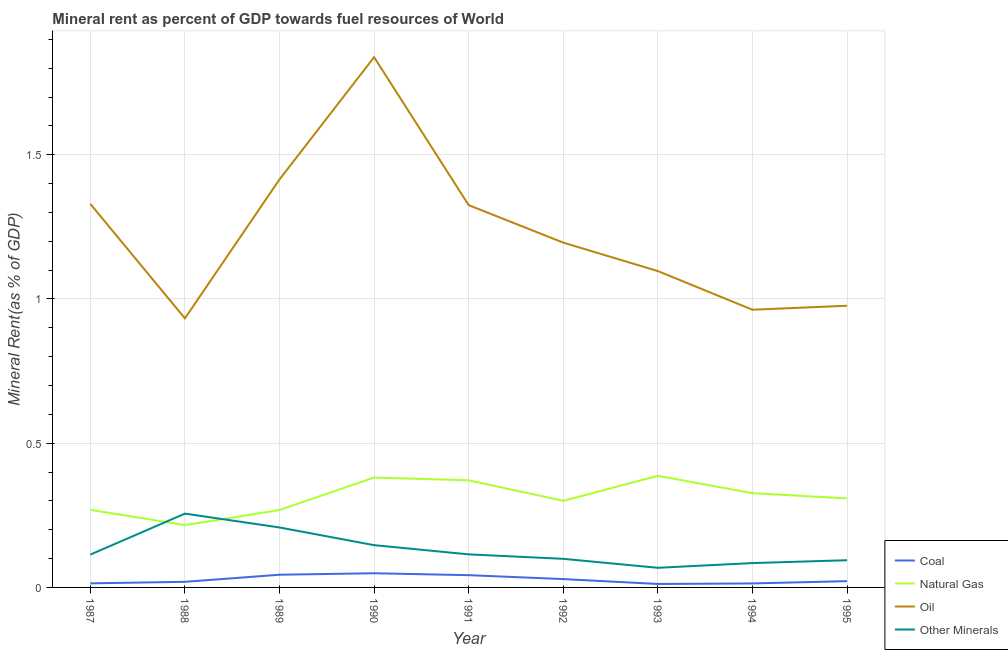How many different coloured lines are there?
Ensure brevity in your answer.  4. Does the line corresponding to natural gas rent intersect with the line corresponding to oil rent?
Offer a terse response. No. Is the number of lines equal to the number of legend labels?
Keep it short and to the point. Yes. What is the natural gas rent in 1991?
Keep it short and to the point. 0.37. Across all years, what is the maximum  rent of other minerals?
Ensure brevity in your answer.  0.26. Across all years, what is the minimum coal rent?
Offer a terse response. 0.01. In which year was the natural gas rent maximum?
Make the answer very short. 1993. In which year was the oil rent minimum?
Provide a succinct answer. 1988. What is the total natural gas rent in the graph?
Your answer should be very brief. 2.83. What is the difference between the oil rent in 1989 and that in 1991?
Your response must be concise. 0.09. What is the difference between the  rent of other minerals in 1987 and the oil rent in 1990?
Offer a terse response. -1.72. What is the average natural gas rent per year?
Provide a short and direct response. 0.31. In the year 1990, what is the difference between the coal rent and natural gas rent?
Your response must be concise. -0.33. In how many years, is the oil rent greater than 1.6 %?
Your answer should be compact. 1. What is the ratio of the coal rent in 1987 to that in 1993?
Provide a succinct answer. 1.18. What is the difference between the highest and the second highest  rent of other minerals?
Provide a succinct answer. 0.05. What is the difference between the highest and the lowest coal rent?
Make the answer very short. 0.04. In how many years, is the  rent of other minerals greater than the average  rent of other minerals taken over all years?
Keep it short and to the point. 3. Is it the case that in every year, the sum of the coal rent and natural gas rent is greater than the oil rent?
Make the answer very short. No. Does the  rent of other minerals monotonically increase over the years?
Provide a succinct answer. No. Is the coal rent strictly greater than the natural gas rent over the years?
Offer a terse response. No. How many years are there in the graph?
Keep it short and to the point. 9. Are the values on the major ticks of Y-axis written in scientific E-notation?
Make the answer very short. No. Where does the legend appear in the graph?
Provide a succinct answer. Bottom right. How are the legend labels stacked?
Give a very brief answer. Vertical. What is the title of the graph?
Provide a succinct answer. Mineral rent as percent of GDP towards fuel resources of World. What is the label or title of the X-axis?
Make the answer very short. Year. What is the label or title of the Y-axis?
Your answer should be compact. Mineral Rent(as % of GDP). What is the Mineral Rent(as % of GDP) of Coal in 1987?
Your answer should be very brief. 0.01. What is the Mineral Rent(as % of GDP) in Natural Gas in 1987?
Your response must be concise. 0.27. What is the Mineral Rent(as % of GDP) of Oil in 1987?
Keep it short and to the point. 1.33. What is the Mineral Rent(as % of GDP) in Other Minerals in 1987?
Your answer should be very brief. 0.11. What is the Mineral Rent(as % of GDP) of Coal in 1988?
Your answer should be very brief. 0.02. What is the Mineral Rent(as % of GDP) in Natural Gas in 1988?
Ensure brevity in your answer.  0.22. What is the Mineral Rent(as % of GDP) in Oil in 1988?
Give a very brief answer. 0.93. What is the Mineral Rent(as % of GDP) in Other Minerals in 1988?
Provide a short and direct response. 0.26. What is the Mineral Rent(as % of GDP) in Coal in 1989?
Your response must be concise. 0.04. What is the Mineral Rent(as % of GDP) in Natural Gas in 1989?
Your answer should be compact. 0.27. What is the Mineral Rent(as % of GDP) of Oil in 1989?
Your answer should be compact. 1.41. What is the Mineral Rent(as % of GDP) in Other Minerals in 1989?
Your answer should be compact. 0.21. What is the Mineral Rent(as % of GDP) of Coal in 1990?
Give a very brief answer. 0.05. What is the Mineral Rent(as % of GDP) of Natural Gas in 1990?
Your answer should be very brief. 0.38. What is the Mineral Rent(as % of GDP) in Oil in 1990?
Make the answer very short. 1.84. What is the Mineral Rent(as % of GDP) in Other Minerals in 1990?
Keep it short and to the point. 0.15. What is the Mineral Rent(as % of GDP) in Coal in 1991?
Offer a very short reply. 0.04. What is the Mineral Rent(as % of GDP) of Natural Gas in 1991?
Offer a terse response. 0.37. What is the Mineral Rent(as % of GDP) of Oil in 1991?
Offer a terse response. 1.33. What is the Mineral Rent(as % of GDP) in Other Minerals in 1991?
Your response must be concise. 0.11. What is the Mineral Rent(as % of GDP) in Coal in 1992?
Your answer should be very brief. 0.03. What is the Mineral Rent(as % of GDP) in Natural Gas in 1992?
Give a very brief answer. 0.3. What is the Mineral Rent(as % of GDP) in Oil in 1992?
Your answer should be compact. 1.2. What is the Mineral Rent(as % of GDP) of Other Minerals in 1992?
Provide a short and direct response. 0.1. What is the Mineral Rent(as % of GDP) of Coal in 1993?
Provide a short and direct response. 0.01. What is the Mineral Rent(as % of GDP) in Natural Gas in 1993?
Make the answer very short. 0.39. What is the Mineral Rent(as % of GDP) in Oil in 1993?
Offer a very short reply. 1.1. What is the Mineral Rent(as % of GDP) of Other Minerals in 1993?
Offer a terse response. 0.07. What is the Mineral Rent(as % of GDP) of Coal in 1994?
Ensure brevity in your answer.  0.01. What is the Mineral Rent(as % of GDP) of Natural Gas in 1994?
Offer a terse response. 0.33. What is the Mineral Rent(as % of GDP) of Oil in 1994?
Offer a very short reply. 0.96. What is the Mineral Rent(as % of GDP) in Other Minerals in 1994?
Keep it short and to the point. 0.08. What is the Mineral Rent(as % of GDP) in Coal in 1995?
Your answer should be compact. 0.02. What is the Mineral Rent(as % of GDP) in Natural Gas in 1995?
Provide a short and direct response. 0.31. What is the Mineral Rent(as % of GDP) in Oil in 1995?
Ensure brevity in your answer.  0.98. What is the Mineral Rent(as % of GDP) in Other Minerals in 1995?
Offer a terse response. 0.09. Across all years, what is the maximum Mineral Rent(as % of GDP) of Coal?
Provide a short and direct response. 0.05. Across all years, what is the maximum Mineral Rent(as % of GDP) of Natural Gas?
Offer a very short reply. 0.39. Across all years, what is the maximum Mineral Rent(as % of GDP) of Oil?
Your answer should be compact. 1.84. Across all years, what is the maximum Mineral Rent(as % of GDP) in Other Minerals?
Your answer should be very brief. 0.26. Across all years, what is the minimum Mineral Rent(as % of GDP) of Coal?
Your answer should be very brief. 0.01. Across all years, what is the minimum Mineral Rent(as % of GDP) in Natural Gas?
Your answer should be compact. 0.22. Across all years, what is the minimum Mineral Rent(as % of GDP) of Oil?
Provide a short and direct response. 0.93. Across all years, what is the minimum Mineral Rent(as % of GDP) in Other Minerals?
Give a very brief answer. 0.07. What is the total Mineral Rent(as % of GDP) of Coal in the graph?
Your answer should be very brief. 0.25. What is the total Mineral Rent(as % of GDP) in Natural Gas in the graph?
Provide a succinct answer. 2.83. What is the total Mineral Rent(as % of GDP) in Oil in the graph?
Provide a short and direct response. 11.07. What is the total Mineral Rent(as % of GDP) of Other Minerals in the graph?
Your response must be concise. 1.18. What is the difference between the Mineral Rent(as % of GDP) of Coal in 1987 and that in 1988?
Your answer should be compact. -0.01. What is the difference between the Mineral Rent(as % of GDP) in Natural Gas in 1987 and that in 1988?
Give a very brief answer. 0.05. What is the difference between the Mineral Rent(as % of GDP) in Oil in 1987 and that in 1988?
Ensure brevity in your answer.  0.4. What is the difference between the Mineral Rent(as % of GDP) in Other Minerals in 1987 and that in 1988?
Provide a short and direct response. -0.14. What is the difference between the Mineral Rent(as % of GDP) in Coal in 1987 and that in 1989?
Offer a terse response. -0.03. What is the difference between the Mineral Rent(as % of GDP) in Natural Gas in 1987 and that in 1989?
Ensure brevity in your answer.  0. What is the difference between the Mineral Rent(as % of GDP) of Oil in 1987 and that in 1989?
Offer a terse response. -0.09. What is the difference between the Mineral Rent(as % of GDP) in Other Minerals in 1987 and that in 1989?
Your answer should be compact. -0.09. What is the difference between the Mineral Rent(as % of GDP) of Coal in 1987 and that in 1990?
Give a very brief answer. -0.04. What is the difference between the Mineral Rent(as % of GDP) of Natural Gas in 1987 and that in 1990?
Make the answer very short. -0.11. What is the difference between the Mineral Rent(as % of GDP) in Oil in 1987 and that in 1990?
Your answer should be very brief. -0.51. What is the difference between the Mineral Rent(as % of GDP) in Other Minerals in 1987 and that in 1990?
Offer a very short reply. -0.03. What is the difference between the Mineral Rent(as % of GDP) of Coal in 1987 and that in 1991?
Offer a very short reply. -0.03. What is the difference between the Mineral Rent(as % of GDP) in Natural Gas in 1987 and that in 1991?
Your answer should be very brief. -0.1. What is the difference between the Mineral Rent(as % of GDP) of Oil in 1987 and that in 1991?
Keep it short and to the point. 0. What is the difference between the Mineral Rent(as % of GDP) of Other Minerals in 1987 and that in 1991?
Your answer should be very brief. -0. What is the difference between the Mineral Rent(as % of GDP) in Coal in 1987 and that in 1992?
Offer a very short reply. -0.01. What is the difference between the Mineral Rent(as % of GDP) of Natural Gas in 1987 and that in 1992?
Offer a very short reply. -0.03. What is the difference between the Mineral Rent(as % of GDP) in Oil in 1987 and that in 1992?
Your answer should be very brief. 0.13. What is the difference between the Mineral Rent(as % of GDP) of Other Minerals in 1987 and that in 1992?
Ensure brevity in your answer.  0.01. What is the difference between the Mineral Rent(as % of GDP) in Coal in 1987 and that in 1993?
Keep it short and to the point. 0. What is the difference between the Mineral Rent(as % of GDP) in Natural Gas in 1987 and that in 1993?
Make the answer very short. -0.12. What is the difference between the Mineral Rent(as % of GDP) of Oil in 1987 and that in 1993?
Your answer should be very brief. 0.23. What is the difference between the Mineral Rent(as % of GDP) in Other Minerals in 1987 and that in 1993?
Offer a terse response. 0.05. What is the difference between the Mineral Rent(as % of GDP) in Natural Gas in 1987 and that in 1994?
Keep it short and to the point. -0.06. What is the difference between the Mineral Rent(as % of GDP) of Oil in 1987 and that in 1994?
Your response must be concise. 0.37. What is the difference between the Mineral Rent(as % of GDP) in Other Minerals in 1987 and that in 1994?
Ensure brevity in your answer.  0.03. What is the difference between the Mineral Rent(as % of GDP) in Coal in 1987 and that in 1995?
Your answer should be very brief. -0.01. What is the difference between the Mineral Rent(as % of GDP) in Natural Gas in 1987 and that in 1995?
Your response must be concise. -0.04. What is the difference between the Mineral Rent(as % of GDP) in Oil in 1987 and that in 1995?
Your answer should be compact. 0.35. What is the difference between the Mineral Rent(as % of GDP) in Other Minerals in 1987 and that in 1995?
Ensure brevity in your answer.  0.02. What is the difference between the Mineral Rent(as % of GDP) in Coal in 1988 and that in 1989?
Your response must be concise. -0.02. What is the difference between the Mineral Rent(as % of GDP) of Natural Gas in 1988 and that in 1989?
Provide a succinct answer. -0.05. What is the difference between the Mineral Rent(as % of GDP) of Oil in 1988 and that in 1989?
Give a very brief answer. -0.48. What is the difference between the Mineral Rent(as % of GDP) of Other Minerals in 1988 and that in 1989?
Offer a terse response. 0.05. What is the difference between the Mineral Rent(as % of GDP) of Coal in 1988 and that in 1990?
Provide a succinct answer. -0.03. What is the difference between the Mineral Rent(as % of GDP) of Natural Gas in 1988 and that in 1990?
Make the answer very short. -0.17. What is the difference between the Mineral Rent(as % of GDP) of Oil in 1988 and that in 1990?
Ensure brevity in your answer.  -0.91. What is the difference between the Mineral Rent(as % of GDP) in Other Minerals in 1988 and that in 1990?
Provide a succinct answer. 0.11. What is the difference between the Mineral Rent(as % of GDP) of Coal in 1988 and that in 1991?
Your answer should be very brief. -0.02. What is the difference between the Mineral Rent(as % of GDP) in Natural Gas in 1988 and that in 1991?
Make the answer very short. -0.16. What is the difference between the Mineral Rent(as % of GDP) in Oil in 1988 and that in 1991?
Your answer should be very brief. -0.39. What is the difference between the Mineral Rent(as % of GDP) of Other Minerals in 1988 and that in 1991?
Give a very brief answer. 0.14. What is the difference between the Mineral Rent(as % of GDP) of Coal in 1988 and that in 1992?
Keep it short and to the point. -0.01. What is the difference between the Mineral Rent(as % of GDP) in Natural Gas in 1988 and that in 1992?
Provide a short and direct response. -0.08. What is the difference between the Mineral Rent(as % of GDP) in Oil in 1988 and that in 1992?
Offer a terse response. -0.26. What is the difference between the Mineral Rent(as % of GDP) in Other Minerals in 1988 and that in 1992?
Your answer should be compact. 0.16. What is the difference between the Mineral Rent(as % of GDP) of Coal in 1988 and that in 1993?
Keep it short and to the point. 0.01. What is the difference between the Mineral Rent(as % of GDP) of Natural Gas in 1988 and that in 1993?
Give a very brief answer. -0.17. What is the difference between the Mineral Rent(as % of GDP) in Oil in 1988 and that in 1993?
Make the answer very short. -0.16. What is the difference between the Mineral Rent(as % of GDP) in Other Minerals in 1988 and that in 1993?
Give a very brief answer. 0.19. What is the difference between the Mineral Rent(as % of GDP) of Coal in 1988 and that in 1994?
Offer a terse response. 0.01. What is the difference between the Mineral Rent(as % of GDP) in Natural Gas in 1988 and that in 1994?
Make the answer very short. -0.11. What is the difference between the Mineral Rent(as % of GDP) in Oil in 1988 and that in 1994?
Your answer should be very brief. -0.03. What is the difference between the Mineral Rent(as % of GDP) in Other Minerals in 1988 and that in 1994?
Provide a short and direct response. 0.17. What is the difference between the Mineral Rent(as % of GDP) of Coal in 1988 and that in 1995?
Provide a succinct answer. -0. What is the difference between the Mineral Rent(as % of GDP) of Natural Gas in 1988 and that in 1995?
Make the answer very short. -0.09. What is the difference between the Mineral Rent(as % of GDP) in Oil in 1988 and that in 1995?
Keep it short and to the point. -0.04. What is the difference between the Mineral Rent(as % of GDP) in Other Minerals in 1988 and that in 1995?
Provide a succinct answer. 0.16. What is the difference between the Mineral Rent(as % of GDP) in Coal in 1989 and that in 1990?
Ensure brevity in your answer.  -0.01. What is the difference between the Mineral Rent(as % of GDP) of Natural Gas in 1989 and that in 1990?
Your answer should be very brief. -0.11. What is the difference between the Mineral Rent(as % of GDP) in Oil in 1989 and that in 1990?
Keep it short and to the point. -0.42. What is the difference between the Mineral Rent(as % of GDP) in Other Minerals in 1989 and that in 1990?
Your answer should be compact. 0.06. What is the difference between the Mineral Rent(as % of GDP) in Coal in 1989 and that in 1991?
Your response must be concise. 0. What is the difference between the Mineral Rent(as % of GDP) in Natural Gas in 1989 and that in 1991?
Give a very brief answer. -0.1. What is the difference between the Mineral Rent(as % of GDP) in Oil in 1989 and that in 1991?
Provide a succinct answer. 0.09. What is the difference between the Mineral Rent(as % of GDP) of Other Minerals in 1989 and that in 1991?
Offer a very short reply. 0.09. What is the difference between the Mineral Rent(as % of GDP) of Coal in 1989 and that in 1992?
Keep it short and to the point. 0.02. What is the difference between the Mineral Rent(as % of GDP) in Natural Gas in 1989 and that in 1992?
Your answer should be very brief. -0.03. What is the difference between the Mineral Rent(as % of GDP) of Oil in 1989 and that in 1992?
Offer a terse response. 0.22. What is the difference between the Mineral Rent(as % of GDP) of Other Minerals in 1989 and that in 1992?
Keep it short and to the point. 0.11. What is the difference between the Mineral Rent(as % of GDP) of Coal in 1989 and that in 1993?
Offer a terse response. 0.03. What is the difference between the Mineral Rent(as % of GDP) in Natural Gas in 1989 and that in 1993?
Offer a terse response. -0.12. What is the difference between the Mineral Rent(as % of GDP) of Oil in 1989 and that in 1993?
Your response must be concise. 0.32. What is the difference between the Mineral Rent(as % of GDP) in Other Minerals in 1989 and that in 1993?
Offer a terse response. 0.14. What is the difference between the Mineral Rent(as % of GDP) of Coal in 1989 and that in 1994?
Ensure brevity in your answer.  0.03. What is the difference between the Mineral Rent(as % of GDP) of Natural Gas in 1989 and that in 1994?
Offer a terse response. -0.06. What is the difference between the Mineral Rent(as % of GDP) of Oil in 1989 and that in 1994?
Keep it short and to the point. 0.45. What is the difference between the Mineral Rent(as % of GDP) of Other Minerals in 1989 and that in 1994?
Offer a terse response. 0.12. What is the difference between the Mineral Rent(as % of GDP) of Coal in 1989 and that in 1995?
Provide a succinct answer. 0.02. What is the difference between the Mineral Rent(as % of GDP) of Natural Gas in 1989 and that in 1995?
Make the answer very short. -0.04. What is the difference between the Mineral Rent(as % of GDP) of Oil in 1989 and that in 1995?
Make the answer very short. 0.44. What is the difference between the Mineral Rent(as % of GDP) in Other Minerals in 1989 and that in 1995?
Offer a very short reply. 0.11. What is the difference between the Mineral Rent(as % of GDP) of Coal in 1990 and that in 1991?
Make the answer very short. 0.01. What is the difference between the Mineral Rent(as % of GDP) in Natural Gas in 1990 and that in 1991?
Make the answer very short. 0.01. What is the difference between the Mineral Rent(as % of GDP) of Oil in 1990 and that in 1991?
Provide a short and direct response. 0.51. What is the difference between the Mineral Rent(as % of GDP) of Other Minerals in 1990 and that in 1991?
Provide a short and direct response. 0.03. What is the difference between the Mineral Rent(as % of GDP) in Coal in 1990 and that in 1992?
Keep it short and to the point. 0.02. What is the difference between the Mineral Rent(as % of GDP) of Natural Gas in 1990 and that in 1992?
Your answer should be compact. 0.08. What is the difference between the Mineral Rent(as % of GDP) of Oil in 1990 and that in 1992?
Keep it short and to the point. 0.64. What is the difference between the Mineral Rent(as % of GDP) of Other Minerals in 1990 and that in 1992?
Provide a succinct answer. 0.05. What is the difference between the Mineral Rent(as % of GDP) in Coal in 1990 and that in 1993?
Offer a very short reply. 0.04. What is the difference between the Mineral Rent(as % of GDP) of Natural Gas in 1990 and that in 1993?
Your answer should be very brief. -0.01. What is the difference between the Mineral Rent(as % of GDP) of Oil in 1990 and that in 1993?
Provide a succinct answer. 0.74. What is the difference between the Mineral Rent(as % of GDP) in Other Minerals in 1990 and that in 1993?
Provide a short and direct response. 0.08. What is the difference between the Mineral Rent(as % of GDP) of Coal in 1990 and that in 1994?
Offer a very short reply. 0.04. What is the difference between the Mineral Rent(as % of GDP) of Natural Gas in 1990 and that in 1994?
Provide a succinct answer. 0.05. What is the difference between the Mineral Rent(as % of GDP) of Oil in 1990 and that in 1994?
Provide a succinct answer. 0.88. What is the difference between the Mineral Rent(as % of GDP) of Other Minerals in 1990 and that in 1994?
Offer a terse response. 0.06. What is the difference between the Mineral Rent(as % of GDP) in Coal in 1990 and that in 1995?
Offer a very short reply. 0.03. What is the difference between the Mineral Rent(as % of GDP) of Natural Gas in 1990 and that in 1995?
Keep it short and to the point. 0.07. What is the difference between the Mineral Rent(as % of GDP) of Oil in 1990 and that in 1995?
Make the answer very short. 0.86. What is the difference between the Mineral Rent(as % of GDP) of Other Minerals in 1990 and that in 1995?
Offer a terse response. 0.05. What is the difference between the Mineral Rent(as % of GDP) of Coal in 1991 and that in 1992?
Your response must be concise. 0.01. What is the difference between the Mineral Rent(as % of GDP) in Natural Gas in 1991 and that in 1992?
Ensure brevity in your answer.  0.07. What is the difference between the Mineral Rent(as % of GDP) of Oil in 1991 and that in 1992?
Provide a succinct answer. 0.13. What is the difference between the Mineral Rent(as % of GDP) in Other Minerals in 1991 and that in 1992?
Provide a short and direct response. 0.02. What is the difference between the Mineral Rent(as % of GDP) in Coal in 1991 and that in 1993?
Offer a terse response. 0.03. What is the difference between the Mineral Rent(as % of GDP) of Natural Gas in 1991 and that in 1993?
Your response must be concise. -0.02. What is the difference between the Mineral Rent(as % of GDP) in Oil in 1991 and that in 1993?
Make the answer very short. 0.23. What is the difference between the Mineral Rent(as % of GDP) in Other Minerals in 1991 and that in 1993?
Offer a very short reply. 0.05. What is the difference between the Mineral Rent(as % of GDP) of Coal in 1991 and that in 1994?
Ensure brevity in your answer.  0.03. What is the difference between the Mineral Rent(as % of GDP) of Natural Gas in 1991 and that in 1994?
Give a very brief answer. 0.04. What is the difference between the Mineral Rent(as % of GDP) of Oil in 1991 and that in 1994?
Make the answer very short. 0.36. What is the difference between the Mineral Rent(as % of GDP) of Other Minerals in 1991 and that in 1994?
Ensure brevity in your answer.  0.03. What is the difference between the Mineral Rent(as % of GDP) of Coal in 1991 and that in 1995?
Your answer should be very brief. 0.02. What is the difference between the Mineral Rent(as % of GDP) of Natural Gas in 1991 and that in 1995?
Your response must be concise. 0.06. What is the difference between the Mineral Rent(as % of GDP) of Oil in 1991 and that in 1995?
Offer a very short reply. 0.35. What is the difference between the Mineral Rent(as % of GDP) of Other Minerals in 1991 and that in 1995?
Provide a succinct answer. 0.02. What is the difference between the Mineral Rent(as % of GDP) of Coal in 1992 and that in 1993?
Provide a succinct answer. 0.02. What is the difference between the Mineral Rent(as % of GDP) of Natural Gas in 1992 and that in 1993?
Your answer should be very brief. -0.09. What is the difference between the Mineral Rent(as % of GDP) in Oil in 1992 and that in 1993?
Ensure brevity in your answer.  0.1. What is the difference between the Mineral Rent(as % of GDP) of Other Minerals in 1992 and that in 1993?
Your response must be concise. 0.03. What is the difference between the Mineral Rent(as % of GDP) of Coal in 1992 and that in 1994?
Your answer should be very brief. 0.02. What is the difference between the Mineral Rent(as % of GDP) of Natural Gas in 1992 and that in 1994?
Your response must be concise. -0.03. What is the difference between the Mineral Rent(as % of GDP) of Oil in 1992 and that in 1994?
Make the answer very short. 0.23. What is the difference between the Mineral Rent(as % of GDP) in Other Minerals in 1992 and that in 1994?
Give a very brief answer. 0.01. What is the difference between the Mineral Rent(as % of GDP) in Coal in 1992 and that in 1995?
Your answer should be very brief. 0.01. What is the difference between the Mineral Rent(as % of GDP) of Natural Gas in 1992 and that in 1995?
Offer a very short reply. -0.01. What is the difference between the Mineral Rent(as % of GDP) in Oil in 1992 and that in 1995?
Your answer should be very brief. 0.22. What is the difference between the Mineral Rent(as % of GDP) in Other Minerals in 1992 and that in 1995?
Provide a short and direct response. 0. What is the difference between the Mineral Rent(as % of GDP) in Coal in 1993 and that in 1994?
Give a very brief answer. -0. What is the difference between the Mineral Rent(as % of GDP) in Natural Gas in 1993 and that in 1994?
Your answer should be very brief. 0.06. What is the difference between the Mineral Rent(as % of GDP) of Oil in 1993 and that in 1994?
Provide a succinct answer. 0.13. What is the difference between the Mineral Rent(as % of GDP) of Other Minerals in 1993 and that in 1994?
Your answer should be compact. -0.02. What is the difference between the Mineral Rent(as % of GDP) in Coal in 1993 and that in 1995?
Offer a terse response. -0.01. What is the difference between the Mineral Rent(as % of GDP) in Natural Gas in 1993 and that in 1995?
Your answer should be compact. 0.08. What is the difference between the Mineral Rent(as % of GDP) in Oil in 1993 and that in 1995?
Your answer should be very brief. 0.12. What is the difference between the Mineral Rent(as % of GDP) of Other Minerals in 1993 and that in 1995?
Your response must be concise. -0.03. What is the difference between the Mineral Rent(as % of GDP) in Coal in 1994 and that in 1995?
Your answer should be compact. -0.01. What is the difference between the Mineral Rent(as % of GDP) of Natural Gas in 1994 and that in 1995?
Your response must be concise. 0.02. What is the difference between the Mineral Rent(as % of GDP) in Oil in 1994 and that in 1995?
Keep it short and to the point. -0.01. What is the difference between the Mineral Rent(as % of GDP) of Other Minerals in 1994 and that in 1995?
Keep it short and to the point. -0.01. What is the difference between the Mineral Rent(as % of GDP) of Coal in 1987 and the Mineral Rent(as % of GDP) of Natural Gas in 1988?
Offer a terse response. -0.2. What is the difference between the Mineral Rent(as % of GDP) of Coal in 1987 and the Mineral Rent(as % of GDP) of Oil in 1988?
Provide a short and direct response. -0.92. What is the difference between the Mineral Rent(as % of GDP) in Coal in 1987 and the Mineral Rent(as % of GDP) in Other Minerals in 1988?
Your answer should be compact. -0.24. What is the difference between the Mineral Rent(as % of GDP) of Natural Gas in 1987 and the Mineral Rent(as % of GDP) of Oil in 1988?
Offer a very short reply. -0.66. What is the difference between the Mineral Rent(as % of GDP) of Natural Gas in 1987 and the Mineral Rent(as % of GDP) of Other Minerals in 1988?
Provide a short and direct response. 0.01. What is the difference between the Mineral Rent(as % of GDP) in Oil in 1987 and the Mineral Rent(as % of GDP) in Other Minerals in 1988?
Your answer should be compact. 1.07. What is the difference between the Mineral Rent(as % of GDP) of Coal in 1987 and the Mineral Rent(as % of GDP) of Natural Gas in 1989?
Make the answer very short. -0.25. What is the difference between the Mineral Rent(as % of GDP) of Coal in 1987 and the Mineral Rent(as % of GDP) of Oil in 1989?
Offer a terse response. -1.4. What is the difference between the Mineral Rent(as % of GDP) of Coal in 1987 and the Mineral Rent(as % of GDP) of Other Minerals in 1989?
Ensure brevity in your answer.  -0.19. What is the difference between the Mineral Rent(as % of GDP) of Natural Gas in 1987 and the Mineral Rent(as % of GDP) of Oil in 1989?
Offer a terse response. -1.15. What is the difference between the Mineral Rent(as % of GDP) of Natural Gas in 1987 and the Mineral Rent(as % of GDP) of Other Minerals in 1989?
Your answer should be compact. 0.06. What is the difference between the Mineral Rent(as % of GDP) in Oil in 1987 and the Mineral Rent(as % of GDP) in Other Minerals in 1989?
Offer a very short reply. 1.12. What is the difference between the Mineral Rent(as % of GDP) in Coal in 1987 and the Mineral Rent(as % of GDP) in Natural Gas in 1990?
Your answer should be compact. -0.37. What is the difference between the Mineral Rent(as % of GDP) of Coal in 1987 and the Mineral Rent(as % of GDP) of Oil in 1990?
Provide a succinct answer. -1.82. What is the difference between the Mineral Rent(as % of GDP) of Coal in 1987 and the Mineral Rent(as % of GDP) of Other Minerals in 1990?
Your response must be concise. -0.13. What is the difference between the Mineral Rent(as % of GDP) in Natural Gas in 1987 and the Mineral Rent(as % of GDP) in Oil in 1990?
Ensure brevity in your answer.  -1.57. What is the difference between the Mineral Rent(as % of GDP) in Natural Gas in 1987 and the Mineral Rent(as % of GDP) in Other Minerals in 1990?
Make the answer very short. 0.12. What is the difference between the Mineral Rent(as % of GDP) of Oil in 1987 and the Mineral Rent(as % of GDP) of Other Minerals in 1990?
Your answer should be compact. 1.18. What is the difference between the Mineral Rent(as % of GDP) in Coal in 1987 and the Mineral Rent(as % of GDP) in Natural Gas in 1991?
Provide a succinct answer. -0.36. What is the difference between the Mineral Rent(as % of GDP) of Coal in 1987 and the Mineral Rent(as % of GDP) of Oil in 1991?
Your answer should be compact. -1.31. What is the difference between the Mineral Rent(as % of GDP) of Coal in 1987 and the Mineral Rent(as % of GDP) of Other Minerals in 1991?
Ensure brevity in your answer.  -0.1. What is the difference between the Mineral Rent(as % of GDP) of Natural Gas in 1987 and the Mineral Rent(as % of GDP) of Oil in 1991?
Your answer should be very brief. -1.06. What is the difference between the Mineral Rent(as % of GDP) of Natural Gas in 1987 and the Mineral Rent(as % of GDP) of Other Minerals in 1991?
Give a very brief answer. 0.15. What is the difference between the Mineral Rent(as % of GDP) of Oil in 1987 and the Mineral Rent(as % of GDP) of Other Minerals in 1991?
Your response must be concise. 1.21. What is the difference between the Mineral Rent(as % of GDP) in Coal in 1987 and the Mineral Rent(as % of GDP) in Natural Gas in 1992?
Make the answer very short. -0.29. What is the difference between the Mineral Rent(as % of GDP) in Coal in 1987 and the Mineral Rent(as % of GDP) in Oil in 1992?
Offer a very short reply. -1.18. What is the difference between the Mineral Rent(as % of GDP) of Coal in 1987 and the Mineral Rent(as % of GDP) of Other Minerals in 1992?
Your answer should be very brief. -0.09. What is the difference between the Mineral Rent(as % of GDP) in Natural Gas in 1987 and the Mineral Rent(as % of GDP) in Oil in 1992?
Your response must be concise. -0.93. What is the difference between the Mineral Rent(as % of GDP) in Natural Gas in 1987 and the Mineral Rent(as % of GDP) in Other Minerals in 1992?
Your answer should be compact. 0.17. What is the difference between the Mineral Rent(as % of GDP) of Oil in 1987 and the Mineral Rent(as % of GDP) of Other Minerals in 1992?
Offer a very short reply. 1.23. What is the difference between the Mineral Rent(as % of GDP) in Coal in 1987 and the Mineral Rent(as % of GDP) in Natural Gas in 1993?
Keep it short and to the point. -0.37. What is the difference between the Mineral Rent(as % of GDP) in Coal in 1987 and the Mineral Rent(as % of GDP) in Oil in 1993?
Provide a short and direct response. -1.08. What is the difference between the Mineral Rent(as % of GDP) of Coal in 1987 and the Mineral Rent(as % of GDP) of Other Minerals in 1993?
Offer a terse response. -0.05. What is the difference between the Mineral Rent(as % of GDP) of Natural Gas in 1987 and the Mineral Rent(as % of GDP) of Oil in 1993?
Your answer should be compact. -0.83. What is the difference between the Mineral Rent(as % of GDP) of Natural Gas in 1987 and the Mineral Rent(as % of GDP) of Other Minerals in 1993?
Your response must be concise. 0.2. What is the difference between the Mineral Rent(as % of GDP) in Oil in 1987 and the Mineral Rent(as % of GDP) in Other Minerals in 1993?
Your answer should be compact. 1.26. What is the difference between the Mineral Rent(as % of GDP) of Coal in 1987 and the Mineral Rent(as % of GDP) of Natural Gas in 1994?
Give a very brief answer. -0.31. What is the difference between the Mineral Rent(as % of GDP) in Coal in 1987 and the Mineral Rent(as % of GDP) in Oil in 1994?
Provide a short and direct response. -0.95. What is the difference between the Mineral Rent(as % of GDP) of Coal in 1987 and the Mineral Rent(as % of GDP) of Other Minerals in 1994?
Make the answer very short. -0.07. What is the difference between the Mineral Rent(as % of GDP) in Natural Gas in 1987 and the Mineral Rent(as % of GDP) in Oil in 1994?
Your response must be concise. -0.69. What is the difference between the Mineral Rent(as % of GDP) of Natural Gas in 1987 and the Mineral Rent(as % of GDP) of Other Minerals in 1994?
Ensure brevity in your answer.  0.18. What is the difference between the Mineral Rent(as % of GDP) of Oil in 1987 and the Mineral Rent(as % of GDP) of Other Minerals in 1994?
Your response must be concise. 1.25. What is the difference between the Mineral Rent(as % of GDP) in Coal in 1987 and the Mineral Rent(as % of GDP) in Natural Gas in 1995?
Offer a terse response. -0.29. What is the difference between the Mineral Rent(as % of GDP) in Coal in 1987 and the Mineral Rent(as % of GDP) in Oil in 1995?
Offer a very short reply. -0.96. What is the difference between the Mineral Rent(as % of GDP) in Coal in 1987 and the Mineral Rent(as % of GDP) in Other Minerals in 1995?
Provide a succinct answer. -0.08. What is the difference between the Mineral Rent(as % of GDP) in Natural Gas in 1987 and the Mineral Rent(as % of GDP) in Oil in 1995?
Provide a short and direct response. -0.71. What is the difference between the Mineral Rent(as % of GDP) in Natural Gas in 1987 and the Mineral Rent(as % of GDP) in Other Minerals in 1995?
Make the answer very short. 0.17. What is the difference between the Mineral Rent(as % of GDP) in Oil in 1987 and the Mineral Rent(as % of GDP) in Other Minerals in 1995?
Give a very brief answer. 1.24. What is the difference between the Mineral Rent(as % of GDP) of Coal in 1988 and the Mineral Rent(as % of GDP) of Natural Gas in 1989?
Your answer should be compact. -0.25. What is the difference between the Mineral Rent(as % of GDP) of Coal in 1988 and the Mineral Rent(as % of GDP) of Oil in 1989?
Your response must be concise. -1.4. What is the difference between the Mineral Rent(as % of GDP) of Coal in 1988 and the Mineral Rent(as % of GDP) of Other Minerals in 1989?
Keep it short and to the point. -0.19. What is the difference between the Mineral Rent(as % of GDP) of Natural Gas in 1988 and the Mineral Rent(as % of GDP) of Oil in 1989?
Provide a succinct answer. -1.2. What is the difference between the Mineral Rent(as % of GDP) of Natural Gas in 1988 and the Mineral Rent(as % of GDP) of Other Minerals in 1989?
Your answer should be very brief. 0.01. What is the difference between the Mineral Rent(as % of GDP) in Oil in 1988 and the Mineral Rent(as % of GDP) in Other Minerals in 1989?
Provide a succinct answer. 0.72. What is the difference between the Mineral Rent(as % of GDP) of Coal in 1988 and the Mineral Rent(as % of GDP) of Natural Gas in 1990?
Provide a succinct answer. -0.36. What is the difference between the Mineral Rent(as % of GDP) of Coal in 1988 and the Mineral Rent(as % of GDP) of Oil in 1990?
Keep it short and to the point. -1.82. What is the difference between the Mineral Rent(as % of GDP) of Coal in 1988 and the Mineral Rent(as % of GDP) of Other Minerals in 1990?
Your answer should be compact. -0.13. What is the difference between the Mineral Rent(as % of GDP) in Natural Gas in 1988 and the Mineral Rent(as % of GDP) in Oil in 1990?
Give a very brief answer. -1.62. What is the difference between the Mineral Rent(as % of GDP) of Natural Gas in 1988 and the Mineral Rent(as % of GDP) of Other Minerals in 1990?
Make the answer very short. 0.07. What is the difference between the Mineral Rent(as % of GDP) in Oil in 1988 and the Mineral Rent(as % of GDP) in Other Minerals in 1990?
Keep it short and to the point. 0.79. What is the difference between the Mineral Rent(as % of GDP) of Coal in 1988 and the Mineral Rent(as % of GDP) of Natural Gas in 1991?
Your response must be concise. -0.35. What is the difference between the Mineral Rent(as % of GDP) of Coal in 1988 and the Mineral Rent(as % of GDP) of Oil in 1991?
Your answer should be compact. -1.31. What is the difference between the Mineral Rent(as % of GDP) in Coal in 1988 and the Mineral Rent(as % of GDP) in Other Minerals in 1991?
Keep it short and to the point. -0.1. What is the difference between the Mineral Rent(as % of GDP) in Natural Gas in 1988 and the Mineral Rent(as % of GDP) in Oil in 1991?
Your answer should be compact. -1.11. What is the difference between the Mineral Rent(as % of GDP) in Natural Gas in 1988 and the Mineral Rent(as % of GDP) in Other Minerals in 1991?
Give a very brief answer. 0.1. What is the difference between the Mineral Rent(as % of GDP) of Oil in 1988 and the Mineral Rent(as % of GDP) of Other Minerals in 1991?
Provide a short and direct response. 0.82. What is the difference between the Mineral Rent(as % of GDP) in Coal in 1988 and the Mineral Rent(as % of GDP) in Natural Gas in 1992?
Ensure brevity in your answer.  -0.28. What is the difference between the Mineral Rent(as % of GDP) in Coal in 1988 and the Mineral Rent(as % of GDP) in Oil in 1992?
Provide a succinct answer. -1.18. What is the difference between the Mineral Rent(as % of GDP) in Coal in 1988 and the Mineral Rent(as % of GDP) in Other Minerals in 1992?
Make the answer very short. -0.08. What is the difference between the Mineral Rent(as % of GDP) of Natural Gas in 1988 and the Mineral Rent(as % of GDP) of Oil in 1992?
Your answer should be compact. -0.98. What is the difference between the Mineral Rent(as % of GDP) of Natural Gas in 1988 and the Mineral Rent(as % of GDP) of Other Minerals in 1992?
Offer a terse response. 0.12. What is the difference between the Mineral Rent(as % of GDP) in Oil in 1988 and the Mineral Rent(as % of GDP) in Other Minerals in 1992?
Your answer should be compact. 0.83. What is the difference between the Mineral Rent(as % of GDP) in Coal in 1988 and the Mineral Rent(as % of GDP) in Natural Gas in 1993?
Offer a very short reply. -0.37. What is the difference between the Mineral Rent(as % of GDP) in Coal in 1988 and the Mineral Rent(as % of GDP) in Oil in 1993?
Ensure brevity in your answer.  -1.08. What is the difference between the Mineral Rent(as % of GDP) of Coal in 1988 and the Mineral Rent(as % of GDP) of Other Minerals in 1993?
Offer a terse response. -0.05. What is the difference between the Mineral Rent(as % of GDP) of Natural Gas in 1988 and the Mineral Rent(as % of GDP) of Oil in 1993?
Make the answer very short. -0.88. What is the difference between the Mineral Rent(as % of GDP) of Natural Gas in 1988 and the Mineral Rent(as % of GDP) of Other Minerals in 1993?
Ensure brevity in your answer.  0.15. What is the difference between the Mineral Rent(as % of GDP) of Oil in 1988 and the Mineral Rent(as % of GDP) of Other Minerals in 1993?
Give a very brief answer. 0.86. What is the difference between the Mineral Rent(as % of GDP) in Coal in 1988 and the Mineral Rent(as % of GDP) in Natural Gas in 1994?
Provide a succinct answer. -0.31. What is the difference between the Mineral Rent(as % of GDP) in Coal in 1988 and the Mineral Rent(as % of GDP) in Oil in 1994?
Offer a very short reply. -0.94. What is the difference between the Mineral Rent(as % of GDP) of Coal in 1988 and the Mineral Rent(as % of GDP) of Other Minerals in 1994?
Give a very brief answer. -0.07. What is the difference between the Mineral Rent(as % of GDP) in Natural Gas in 1988 and the Mineral Rent(as % of GDP) in Oil in 1994?
Ensure brevity in your answer.  -0.75. What is the difference between the Mineral Rent(as % of GDP) of Natural Gas in 1988 and the Mineral Rent(as % of GDP) of Other Minerals in 1994?
Provide a short and direct response. 0.13. What is the difference between the Mineral Rent(as % of GDP) in Oil in 1988 and the Mineral Rent(as % of GDP) in Other Minerals in 1994?
Make the answer very short. 0.85. What is the difference between the Mineral Rent(as % of GDP) in Coal in 1988 and the Mineral Rent(as % of GDP) in Natural Gas in 1995?
Provide a succinct answer. -0.29. What is the difference between the Mineral Rent(as % of GDP) in Coal in 1988 and the Mineral Rent(as % of GDP) in Oil in 1995?
Offer a very short reply. -0.96. What is the difference between the Mineral Rent(as % of GDP) in Coal in 1988 and the Mineral Rent(as % of GDP) in Other Minerals in 1995?
Keep it short and to the point. -0.07. What is the difference between the Mineral Rent(as % of GDP) in Natural Gas in 1988 and the Mineral Rent(as % of GDP) in Oil in 1995?
Your answer should be compact. -0.76. What is the difference between the Mineral Rent(as % of GDP) in Natural Gas in 1988 and the Mineral Rent(as % of GDP) in Other Minerals in 1995?
Make the answer very short. 0.12. What is the difference between the Mineral Rent(as % of GDP) in Oil in 1988 and the Mineral Rent(as % of GDP) in Other Minerals in 1995?
Ensure brevity in your answer.  0.84. What is the difference between the Mineral Rent(as % of GDP) of Coal in 1989 and the Mineral Rent(as % of GDP) of Natural Gas in 1990?
Provide a short and direct response. -0.34. What is the difference between the Mineral Rent(as % of GDP) of Coal in 1989 and the Mineral Rent(as % of GDP) of Oil in 1990?
Keep it short and to the point. -1.79. What is the difference between the Mineral Rent(as % of GDP) of Coal in 1989 and the Mineral Rent(as % of GDP) of Other Minerals in 1990?
Provide a short and direct response. -0.1. What is the difference between the Mineral Rent(as % of GDP) of Natural Gas in 1989 and the Mineral Rent(as % of GDP) of Oil in 1990?
Your response must be concise. -1.57. What is the difference between the Mineral Rent(as % of GDP) of Natural Gas in 1989 and the Mineral Rent(as % of GDP) of Other Minerals in 1990?
Ensure brevity in your answer.  0.12. What is the difference between the Mineral Rent(as % of GDP) in Oil in 1989 and the Mineral Rent(as % of GDP) in Other Minerals in 1990?
Your response must be concise. 1.27. What is the difference between the Mineral Rent(as % of GDP) in Coal in 1989 and the Mineral Rent(as % of GDP) in Natural Gas in 1991?
Provide a succinct answer. -0.33. What is the difference between the Mineral Rent(as % of GDP) in Coal in 1989 and the Mineral Rent(as % of GDP) in Oil in 1991?
Your answer should be very brief. -1.28. What is the difference between the Mineral Rent(as % of GDP) in Coal in 1989 and the Mineral Rent(as % of GDP) in Other Minerals in 1991?
Your response must be concise. -0.07. What is the difference between the Mineral Rent(as % of GDP) of Natural Gas in 1989 and the Mineral Rent(as % of GDP) of Oil in 1991?
Offer a very short reply. -1.06. What is the difference between the Mineral Rent(as % of GDP) of Natural Gas in 1989 and the Mineral Rent(as % of GDP) of Other Minerals in 1991?
Make the answer very short. 0.15. What is the difference between the Mineral Rent(as % of GDP) of Oil in 1989 and the Mineral Rent(as % of GDP) of Other Minerals in 1991?
Ensure brevity in your answer.  1.3. What is the difference between the Mineral Rent(as % of GDP) of Coal in 1989 and the Mineral Rent(as % of GDP) of Natural Gas in 1992?
Offer a very short reply. -0.26. What is the difference between the Mineral Rent(as % of GDP) in Coal in 1989 and the Mineral Rent(as % of GDP) in Oil in 1992?
Make the answer very short. -1.15. What is the difference between the Mineral Rent(as % of GDP) of Coal in 1989 and the Mineral Rent(as % of GDP) of Other Minerals in 1992?
Keep it short and to the point. -0.06. What is the difference between the Mineral Rent(as % of GDP) in Natural Gas in 1989 and the Mineral Rent(as % of GDP) in Oil in 1992?
Offer a very short reply. -0.93. What is the difference between the Mineral Rent(as % of GDP) in Natural Gas in 1989 and the Mineral Rent(as % of GDP) in Other Minerals in 1992?
Your answer should be compact. 0.17. What is the difference between the Mineral Rent(as % of GDP) of Oil in 1989 and the Mineral Rent(as % of GDP) of Other Minerals in 1992?
Your answer should be very brief. 1.32. What is the difference between the Mineral Rent(as % of GDP) of Coal in 1989 and the Mineral Rent(as % of GDP) of Natural Gas in 1993?
Your response must be concise. -0.34. What is the difference between the Mineral Rent(as % of GDP) of Coal in 1989 and the Mineral Rent(as % of GDP) of Oil in 1993?
Your answer should be very brief. -1.05. What is the difference between the Mineral Rent(as % of GDP) in Coal in 1989 and the Mineral Rent(as % of GDP) in Other Minerals in 1993?
Offer a terse response. -0.02. What is the difference between the Mineral Rent(as % of GDP) in Natural Gas in 1989 and the Mineral Rent(as % of GDP) in Oil in 1993?
Give a very brief answer. -0.83. What is the difference between the Mineral Rent(as % of GDP) in Natural Gas in 1989 and the Mineral Rent(as % of GDP) in Other Minerals in 1993?
Ensure brevity in your answer.  0.2. What is the difference between the Mineral Rent(as % of GDP) in Oil in 1989 and the Mineral Rent(as % of GDP) in Other Minerals in 1993?
Your answer should be very brief. 1.35. What is the difference between the Mineral Rent(as % of GDP) of Coal in 1989 and the Mineral Rent(as % of GDP) of Natural Gas in 1994?
Make the answer very short. -0.28. What is the difference between the Mineral Rent(as % of GDP) in Coal in 1989 and the Mineral Rent(as % of GDP) in Oil in 1994?
Make the answer very short. -0.92. What is the difference between the Mineral Rent(as % of GDP) in Coal in 1989 and the Mineral Rent(as % of GDP) in Other Minerals in 1994?
Keep it short and to the point. -0.04. What is the difference between the Mineral Rent(as % of GDP) of Natural Gas in 1989 and the Mineral Rent(as % of GDP) of Oil in 1994?
Make the answer very short. -0.69. What is the difference between the Mineral Rent(as % of GDP) of Natural Gas in 1989 and the Mineral Rent(as % of GDP) of Other Minerals in 1994?
Give a very brief answer. 0.18. What is the difference between the Mineral Rent(as % of GDP) of Oil in 1989 and the Mineral Rent(as % of GDP) of Other Minerals in 1994?
Provide a short and direct response. 1.33. What is the difference between the Mineral Rent(as % of GDP) of Coal in 1989 and the Mineral Rent(as % of GDP) of Natural Gas in 1995?
Keep it short and to the point. -0.26. What is the difference between the Mineral Rent(as % of GDP) in Coal in 1989 and the Mineral Rent(as % of GDP) in Oil in 1995?
Make the answer very short. -0.93. What is the difference between the Mineral Rent(as % of GDP) of Coal in 1989 and the Mineral Rent(as % of GDP) of Other Minerals in 1995?
Ensure brevity in your answer.  -0.05. What is the difference between the Mineral Rent(as % of GDP) in Natural Gas in 1989 and the Mineral Rent(as % of GDP) in Oil in 1995?
Keep it short and to the point. -0.71. What is the difference between the Mineral Rent(as % of GDP) in Natural Gas in 1989 and the Mineral Rent(as % of GDP) in Other Minerals in 1995?
Offer a terse response. 0.17. What is the difference between the Mineral Rent(as % of GDP) in Oil in 1989 and the Mineral Rent(as % of GDP) in Other Minerals in 1995?
Ensure brevity in your answer.  1.32. What is the difference between the Mineral Rent(as % of GDP) in Coal in 1990 and the Mineral Rent(as % of GDP) in Natural Gas in 1991?
Your answer should be compact. -0.32. What is the difference between the Mineral Rent(as % of GDP) of Coal in 1990 and the Mineral Rent(as % of GDP) of Oil in 1991?
Provide a succinct answer. -1.28. What is the difference between the Mineral Rent(as % of GDP) of Coal in 1990 and the Mineral Rent(as % of GDP) of Other Minerals in 1991?
Make the answer very short. -0.07. What is the difference between the Mineral Rent(as % of GDP) in Natural Gas in 1990 and the Mineral Rent(as % of GDP) in Oil in 1991?
Keep it short and to the point. -0.94. What is the difference between the Mineral Rent(as % of GDP) in Natural Gas in 1990 and the Mineral Rent(as % of GDP) in Other Minerals in 1991?
Give a very brief answer. 0.27. What is the difference between the Mineral Rent(as % of GDP) of Oil in 1990 and the Mineral Rent(as % of GDP) of Other Minerals in 1991?
Provide a succinct answer. 1.72. What is the difference between the Mineral Rent(as % of GDP) of Coal in 1990 and the Mineral Rent(as % of GDP) of Natural Gas in 1992?
Offer a terse response. -0.25. What is the difference between the Mineral Rent(as % of GDP) in Coal in 1990 and the Mineral Rent(as % of GDP) in Oil in 1992?
Your response must be concise. -1.15. What is the difference between the Mineral Rent(as % of GDP) in Coal in 1990 and the Mineral Rent(as % of GDP) in Other Minerals in 1992?
Ensure brevity in your answer.  -0.05. What is the difference between the Mineral Rent(as % of GDP) of Natural Gas in 1990 and the Mineral Rent(as % of GDP) of Oil in 1992?
Your response must be concise. -0.81. What is the difference between the Mineral Rent(as % of GDP) in Natural Gas in 1990 and the Mineral Rent(as % of GDP) in Other Minerals in 1992?
Your response must be concise. 0.28. What is the difference between the Mineral Rent(as % of GDP) of Oil in 1990 and the Mineral Rent(as % of GDP) of Other Minerals in 1992?
Provide a short and direct response. 1.74. What is the difference between the Mineral Rent(as % of GDP) in Coal in 1990 and the Mineral Rent(as % of GDP) in Natural Gas in 1993?
Your answer should be very brief. -0.34. What is the difference between the Mineral Rent(as % of GDP) in Coal in 1990 and the Mineral Rent(as % of GDP) in Oil in 1993?
Ensure brevity in your answer.  -1.05. What is the difference between the Mineral Rent(as % of GDP) of Coal in 1990 and the Mineral Rent(as % of GDP) of Other Minerals in 1993?
Your answer should be compact. -0.02. What is the difference between the Mineral Rent(as % of GDP) of Natural Gas in 1990 and the Mineral Rent(as % of GDP) of Oil in 1993?
Offer a very short reply. -0.72. What is the difference between the Mineral Rent(as % of GDP) in Natural Gas in 1990 and the Mineral Rent(as % of GDP) in Other Minerals in 1993?
Keep it short and to the point. 0.31. What is the difference between the Mineral Rent(as % of GDP) of Oil in 1990 and the Mineral Rent(as % of GDP) of Other Minerals in 1993?
Offer a terse response. 1.77. What is the difference between the Mineral Rent(as % of GDP) in Coal in 1990 and the Mineral Rent(as % of GDP) in Natural Gas in 1994?
Provide a short and direct response. -0.28. What is the difference between the Mineral Rent(as % of GDP) of Coal in 1990 and the Mineral Rent(as % of GDP) of Oil in 1994?
Ensure brevity in your answer.  -0.91. What is the difference between the Mineral Rent(as % of GDP) of Coal in 1990 and the Mineral Rent(as % of GDP) of Other Minerals in 1994?
Your response must be concise. -0.04. What is the difference between the Mineral Rent(as % of GDP) in Natural Gas in 1990 and the Mineral Rent(as % of GDP) in Oil in 1994?
Your answer should be very brief. -0.58. What is the difference between the Mineral Rent(as % of GDP) in Natural Gas in 1990 and the Mineral Rent(as % of GDP) in Other Minerals in 1994?
Your answer should be very brief. 0.3. What is the difference between the Mineral Rent(as % of GDP) of Oil in 1990 and the Mineral Rent(as % of GDP) of Other Minerals in 1994?
Offer a very short reply. 1.75. What is the difference between the Mineral Rent(as % of GDP) of Coal in 1990 and the Mineral Rent(as % of GDP) of Natural Gas in 1995?
Give a very brief answer. -0.26. What is the difference between the Mineral Rent(as % of GDP) in Coal in 1990 and the Mineral Rent(as % of GDP) in Oil in 1995?
Ensure brevity in your answer.  -0.93. What is the difference between the Mineral Rent(as % of GDP) of Coal in 1990 and the Mineral Rent(as % of GDP) of Other Minerals in 1995?
Give a very brief answer. -0.05. What is the difference between the Mineral Rent(as % of GDP) in Natural Gas in 1990 and the Mineral Rent(as % of GDP) in Oil in 1995?
Make the answer very short. -0.6. What is the difference between the Mineral Rent(as % of GDP) of Natural Gas in 1990 and the Mineral Rent(as % of GDP) of Other Minerals in 1995?
Make the answer very short. 0.29. What is the difference between the Mineral Rent(as % of GDP) in Oil in 1990 and the Mineral Rent(as % of GDP) in Other Minerals in 1995?
Your answer should be compact. 1.74. What is the difference between the Mineral Rent(as % of GDP) of Coal in 1991 and the Mineral Rent(as % of GDP) of Natural Gas in 1992?
Provide a succinct answer. -0.26. What is the difference between the Mineral Rent(as % of GDP) in Coal in 1991 and the Mineral Rent(as % of GDP) in Oil in 1992?
Your answer should be compact. -1.15. What is the difference between the Mineral Rent(as % of GDP) of Coal in 1991 and the Mineral Rent(as % of GDP) of Other Minerals in 1992?
Your answer should be compact. -0.06. What is the difference between the Mineral Rent(as % of GDP) of Natural Gas in 1991 and the Mineral Rent(as % of GDP) of Oil in 1992?
Ensure brevity in your answer.  -0.82. What is the difference between the Mineral Rent(as % of GDP) of Natural Gas in 1991 and the Mineral Rent(as % of GDP) of Other Minerals in 1992?
Give a very brief answer. 0.27. What is the difference between the Mineral Rent(as % of GDP) in Oil in 1991 and the Mineral Rent(as % of GDP) in Other Minerals in 1992?
Your answer should be very brief. 1.23. What is the difference between the Mineral Rent(as % of GDP) of Coal in 1991 and the Mineral Rent(as % of GDP) of Natural Gas in 1993?
Offer a terse response. -0.34. What is the difference between the Mineral Rent(as % of GDP) in Coal in 1991 and the Mineral Rent(as % of GDP) in Oil in 1993?
Keep it short and to the point. -1.05. What is the difference between the Mineral Rent(as % of GDP) in Coal in 1991 and the Mineral Rent(as % of GDP) in Other Minerals in 1993?
Your answer should be compact. -0.03. What is the difference between the Mineral Rent(as % of GDP) of Natural Gas in 1991 and the Mineral Rent(as % of GDP) of Oil in 1993?
Your answer should be very brief. -0.73. What is the difference between the Mineral Rent(as % of GDP) of Natural Gas in 1991 and the Mineral Rent(as % of GDP) of Other Minerals in 1993?
Your response must be concise. 0.3. What is the difference between the Mineral Rent(as % of GDP) of Oil in 1991 and the Mineral Rent(as % of GDP) of Other Minerals in 1993?
Offer a terse response. 1.26. What is the difference between the Mineral Rent(as % of GDP) in Coal in 1991 and the Mineral Rent(as % of GDP) in Natural Gas in 1994?
Provide a short and direct response. -0.28. What is the difference between the Mineral Rent(as % of GDP) in Coal in 1991 and the Mineral Rent(as % of GDP) in Oil in 1994?
Provide a succinct answer. -0.92. What is the difference between the Mineral Rent(as % of GDP) in Coal in 1991 and the Mineral Rent(as % of GDP) in Other Minerals in 1994?
Provide a succinct answer. -0.04. What is the difference between the Mineral Rent(as % of GDP) in Natural Gas in 1991 and the Mineral Rent(as % of GDP) in Oil in 1994?
Ensure brevity in your answer.  -0.59. What is the difference between the Mineral Rent(as % of GDP) in Natural Gas in 1991 and the Mineral Rent(as % of GDP) in Other Minerals in 1994?
Give a very brief answer. 0.29. What is the difference between the Mineral Rent(as % of GDP) in Oil in 1991 and the Mineral Rent(as % of GDP) in Other Minerals in 1994?
Keep it short and to the point. 1.24. What is the difference between the Mineral Rent(as % of GDP) in Coal in 1991 and the Mineral Rent(as % of GDP) in Natural Gas in 1995?
Provide a short and direct response. -0.27. What is the difference between the Mineral Rent(as % of GDP) in Coal in 1991 and the Mineral Rent(as % of GDP) in Oil in 1995?
Make the answer very short. -0.93. What is the difference between the Mineral Rent(as % of GDP) of Coal in 1991 and the Mineral Rent(as % of GDP) of Other Minerals in 1995?
Provide a short and direct response. -0.05. What is the difference between the Mineral Rent(as % of GDP) in Natural Gas in 1991 and the Mineral Rent(as % of GDP) in Oil in 1995?
Offer a very short reply. -0.61. What is the difference between the Mineral Rent(as % of GDP) in Natural Gas in 1991 and the Mineral Rent(as % of GDP) in Other Minerals in 1995?
Give a very brief answer. 0.28. What is the difference between the Mineral Rent(as % of GDP) of Oil in 1991 and the Mineral Rent(as % of GDP) of Other Minerals in 1995?
Keep it short and to the point. 1.23. What is the difference between the Mineral Rent(as % of GDP) of Coal in 1992 and the Mineral Rent(as % of GDP) of Natural Gas in 1993?
Provide a succinct answer. -0.36. What is the difference between the Mineral Rent(as % of GDP) in Coal in 1992 and the Mineral Rent(as % of GDP) in Oil in 1993?
Offer a terse response. -1.07. What is the difference between the Mineral Rent(as % of GDP) in Coal in 1992 and the Mineral Rent(as % of GDP) in Other Minerals in 1993?
Keep it short and to the point. -0.04. What is the difference between the Mineral Rent(as % of GDP) in Natural Gas in 1992 and the Mineral Rent(as % of GDP) in Oil in 1993?
Ensure brevity in your answer.  -0.8. What is the difference between the Mineral Rent(as % of GDP) in Natural Gas in 1992 and the Mineral Rent(as % of GDP) in Other Minerals in 1993?
Ensure brevity in your answer.  0.23. What is the difference between the Mineral Rent(as % of GDP) of Oil in 1992 and the Mineral Rent(as % of GDP) of Other Minerals in 1993?
Your response must be concise. 1.13. What is the difference between the Mineral Rent(as % of GDP) of Coal in 1992 and the Mineral Rent(as % of GDP) of Natural Gas in 1994?
Ensure brevity in your answer.  -0.3. What is the difference between the Mineral Rent(as % of GDP) of Coal in 1992 and the Mineral Rent(as % of GDP) of Oil in 1994?
Your answer should be very brief. -0.93. What is the difference between the Mineral Rent(as % of GDP) in Coal in 1992 and the Mineral Rent(as % of GDP) in Other Minerals in 1994?
Provide a short and direct response. -0.06. What is the difference between the Mineral Rent(as % of GDP) in Natural Gas in 1992 and the Mineral Rent(as % of GDP) in Oil in 1994?
Make the answer very short. -0.66. What is the difference between the Mineral Rent(as % of GDP) in Natural Gas in 1992 and the Mineral Rent(as % of GDP) in Other Minerals in 1994?
Offer a very short reply. 0.22. What is the difference between the Mineral Rent(as % of GDP) in Oil in 1992 and the Mineral Rent(as % of GDP) in Other Minerals in 1994?
Your answer should be compact. 1.11. What is the difference between the Mineral Rent(as % of GDP) of Coal in 1992 and the Mineral Rent(as % of GDP) of Natural Gas in 1995?
Your response must be concise. -0.28. What is the difference between the Mineral Rent(as % of GDP) of Coal in 1992 and the Mineral Rent(as % of GDP) of Oil in 1995?
Offer a very short reply. -0.95. What is the difference between the Mineral Rent(as % of GDP) in Coal in 1992 and the Mineral Rent(as % of GDP) in Other Minerals in 1995?
Your answer should be very brief. -0.07. What is the difference between the Mineral Rent(as % of GDP) of Natural Gas in 1992 and the Mineral Rent(as % of GDP) of Oil in 1995?
Give a very brief answer. -0.68. What is the difference between the Mineral Rent(as % of GDP) in Natural Gas in 1992 and the Mineral Rent(as % of GDP) in Other Minerals in 1995?
Offer a very short reply. 0.21. What is the difference between the Mineral Rent(as % of GDP) of Oil in 1992 and the Mineral Rent(as % of GDP) of Other Minerals in 1995?
Provide a succinct answer. 1.1. What is the difference between the Mineral Rent(as % of GDP) in Coal in 1993 and the Mineral Rent(as % of GDP) in Natural Gas in 1994?
Make the answer very short. -0.31. What is the difference between the Mineral Rent(as % of GDP) in Coal in 1993 and the Mineral Rent(as % of GDP) in Oil in 1994?
Your answer should be compact. -0.95. What is the difference between the Mineral Rent(as % of GDP) in Coal in 1993 and the Mineral Rent(as % of GDP) in Other Minerals in 1994?
Keep it short and to the point. -0.07. What is the difference between the Mineral Rent(as % of GDP) of Natural Gas in 1993 and the Mineral Rent(as % of GDP) of Oil in 1994?
Ensure brevity in your answer.  -0.58. What is the difference between the Mineral Rent(as % of GDP) in Natural Gas in 1993 and the Mineral Rent(as % of GDP) in Other Minerals in 1994?
Offer a terse response. 0.3. What is the difference between the Mineral Rent(as % of GDP) of Oil in 1993 and the Mineral Rent(as % of GDP) of Other Minerals in 1994?
Offer a terse response. 1.01. What is the difference between the Mineral Rent(as % of GDP) of Coal in 1993 and the Mineral Rent(as % of GDP) of Natural Gas in 1995?
Provide a succinct answer. -0.3. What is the difference between the Mineral Rent(as % of GDP) of Coal in 1993 and the Mineral Rent(as % of GDP) of Oil in 1995?
Make the answer very short. -0.96. What is the difference between the Mineral Rent(as % of GDP) in Coal in 1993 and the Mineral Rent(as % of GDP) in Other Minerals in 1995?
Offer a very short reply. -0.08. What is the difference between the Mineral Rent(as % of GDP) in Natural Gas in 1993 and the Mineral Rent(as % of GDP) in Oil in 1995?
Ensure brevity in your answer.  -0.59. What is the difference between the Mineral Rent(as % of GDP) in Natural Gas in 1993 and the Mineral Rent(as % of GDP) in Other Minerals in 1995?
Provide a short and direct response. 0.29. What is the difference between the Mineral Rent(as % of GDP) in Coal in 1994 and the Mineral Rent(as % of GDP) in Natural Gas in 1995?
Offer a very short reply. -0.29. What is the difference between the Mineral Rent(as % of GDP) of Coal in 1994 and the Mineral Rent(as % of GDP) of Oil in 1995?
Keep it short and to the point. -0.96. What is the difference between the Mineral Rent(as % of GDP) in Coal in 1994 and the Mineral Rent(as % of GDP) in Other Minerals in 1995?
Make the answer very short. -0.08. What is the difference between the Mineral Rent(as % of GDP) of Natural Gas in 1994 and the Mineral Rent(as % of GDP) of Oil in 1995?
Offer a terse response. -0.65. What is the difference between the Mineral Rent(as % of GDP) of Natural Gas in 1994 and the Mineral Rent(as % of GDP) of Other Minerals in 1995?
Your answer should be compact. 0.23. What is the difference between the Mineral Rent(as % of GDP) of Oil in 1994 and the Mineral Rent(as % of GDP) of Other Minerals in 1995?
Your response must be concise. 0.87. What is the average Mineral Rent(as % of GDP) in Coal per year?
Provide a succinct answer. 0.03. What is the average Mineral Rent(as % of GDP) in Natural Gas per year?
Provide a succinct answer. 0.31. What is the average Mineral Rent(as % of GDP) in Oil per year?
Provide a short and direct response. 1.23. What is the average Mineral Rent(as % of GDP) of Other Minerals per year?
Offer a terse response. 0.13. In the year 1987, what is the difference between the Mineral Rent(as % of GDP) of Coal and Mineral Rent(as % of GDP) of Natural Gas?
Your response must be concise. -0.25. In the year 1987, what is the difference between the Mineral Rent(as % of GDP) of Coal and Mineral Rent(as % of GDP) of Oil?
Your response must be concise. -1.32. In the year 1987, what is the difference between the Mineral Rent(as % of GDP) of Coal and Mineral Rent(as % of GDP) of Other Minerals?
Your answer should be very brief. -0.1. In the year 1987, what is the difference between the Mineral Rent(as % of GDP) in Natural Gas and Mineral Rent(as % of GDP) in Oil?
Your answer should be very brief. -1.06. In the year 1987, what is the difference between the Mineral Rent(as % of GDP) in Natural Gas and Mineral Rent(as % of GDP) in Other Minerals?
Provide a short and direct response. 0.16. In the year 1987, what is the difference between the Mineral Rent(as % of GDP) of Oil and Mineral Rent(as % of GDP) of Other Minerals?
Offer a terse response. 1.22. In the year 1988, what is the difference between the Mineral Rent(as % of GDP) in Coal and Mineral Rent(as % of GDP) in Natural Gas?
Keep it short and to the point. -0.2. In the year 1988, what is the difference between the Mineral Rent(as % of GDP) in Coal and Mineral Rent(as % of GDP) in Oil?
Provide a short and direct response. -0.91. In the year 1988, what is the difference between the Mineral Rent(as % of GDP) of Coal and Mineral Rent(as % of GDP) of Other Minerals?
Provide a succinct answer. -0.24. In the year 1988, what is the difference between the Mineral Rent(as % of GDP) of Natural Gas and Mineral Rent(as % of GDP) of Oil?
Your answer should be very brief. -0.72. In the year 1988, what is the difference between the Mineral Rent(as % of GDP) of Natural Gas and Mineral Rent(as % of GDP) of Other Minerals?
Your answer should be very brief. -0.04. In the year 1988, what is the difference between the Mineral Rent(as % of GDP) in Oil and Mineral Rent(as % of GDP) in Other Minerals?
Provide a succinct answer. 0.68. In the year 1989, what is the difference between the Mineral Rent(as % of GDP) in Coal and Mineral Rent(as % of GDP) in Natural Gas?
Make the answer very short. -0.22. In the year 1989, what is the difference between the Mineral Rent(as % of GDP) in Coal and Mineral Rent(as % of GDP) in Oil?
Offer a terse response. -1.37. In the year 1989, what is the difference between the Mineral Rent(as % of GDP) of Coal and Mineral Rent(as % of GDP) of Other Minerals?
Keep it short and to the point. -0.16. In the year 1989, what is the difference between the Mineral Rent(as % of GDP) of Natural Gas and Mineral Rent(as % of GDP) of Oil?
Your response must be concise. -1.15. In the year 1989, what is the difference between the Mineral Rent(as % of GDP) of Natural Gas and Mineral Rent(as % of GDP) of Other Minerals?
Give a very brief answer. 0.06. In the year 1989, what is the difference between the Mineral Rent(as % of GDP) of Oil and Mineral Rent(as % of GDP) of Other Minerals?
Provide a succinct answer. 1.21. In the year 1990, what is the difference between the Mineral Rent(as % of GDP) of Coal and Mineral Rent(as % of GDP) of Natural Gas?
Your response must be concise. -0.33. In the year 1990, what is the difference between the Mineral Rent(as % of GDP) in Coal and Mineral Rent(as % of GDP) in Oil?
Your answer should be compact. -1.79. In the year 1990, what is the difference between the Mineral Rent(as % of GDP) in Coal and Mineral Rent(as % of GDP) in Other Minerals?
Provide a succinct answer. -0.1. In the year 1990, what is the difference between the Mineral Rent(as % of GDP) in Natural Gas and Mineral Rent(as % of GDP) in Oil?
Offer a very short reply. -1.46. In the year 1990, what is the difference between the Mineral Rent(as % of GDP) of Natural Gas and Mineral Rent(as % of GDP) of Other Minerals?
Ensure brevity in your answer.  0.23. In the year 1990, what is the difference between the Mineral Rent(as % of GDP) in Oil and Mineral Rent(as % of GDP) in Other Minerals?
Ensure brevity in your answer.  1.69. In the year 1991, what is the difference between the Mineral Rent(as % of GDP) of Coal and Mineral Rent(as % of GDP) of Natural Gas?
Provide a short and direct response. -0.33. In the year 1991, what is the difference between the Mineral Rent(as % of GDP) of Coal and Mineral Rent(as % of GDP) of Oil?
Give a very brief answer. -1.28. In the year 1991, what is the difference between the Mineral Rent(as % of GDP) of Coal and Mineral Rent(as % of GDP) of Other Minerals?
Make the answer very short. -0.07. In the year 1991, what is the difference between the Mineral Rent(as % of GDP) of Natural Gas and Mineral Rent(as % of GDP) of Oil?
Offer a terse response. -0.95. In the year 1991, what is the difference between the Mineral Rent(as % of GDP) of Natural Gas and Mineral Rent(as % of GDP) of Other Minerals?
Your response must be concise. 0.26. In the year 1991, what is the difference between the Mineral Rent(as % of GDP) in Oil and Mineral Rent(as % of GDP) in Other Minerals?
Your answer should be compact. 1.21. In the year 1992, what is the difference between the Mineral Rent(as % of GDP) in Coal and Mineral Rent(as % of GDP) in Natural Gas?
Make the answer very short. -0.27. In the year 1992, what is the difference between the Mineral Rent(as % of GDP) of Coal and Mineral Rent(as % of GDP) of Oil?
Your response must be concise. -1.17. In the year 1992, what is the difference between the Mineral Rent(as % of GDP) in Coal and Mineral Rent(as % of GDP) in Other Minerals?
Your answer should be very brief. -0.07. In the year 1992, what is the difference between the Mineral Rent(as % of GDP) in Natural Gas and Mineral Rent(as % of GDP) in Oil?
Ensure brevity in your answer.  -0.9. In the year 1992, what is the difference between the Mineral Rent(as % of GDP) of Natural Gas and Mineral Rent(as % of GDP) of Other Minerals?
Offer a very short reply. 0.2. In the year 1992, what is the difference between the Mineral Rent(as % of GDP) of Oil and Mineral Rent(as % of GDP) of Other Minerals?
Your answer should be very brief. 1.1. In the year 1993, what is the difference between the Mineral Rent(as % of GDP) of Coal and Mineral Rent(as % of GDP) of Natural Gas?
Provide a succinct answer. -0.37. In the year 1993, what is the difference between the Mineral Rent(as % of GDP) of Coal and Mineral Rent(as % of GDP) of Oil?
Your answer should be compact. -1.08. In the year 1993, what is the difference between the Mineral Rent(as % of GDP) in Coal and Mineral Rent(as % of GDP) in Other Minerals?
Make the answer very short. -0.06. In the year 1993, what is the difference between the Mineral Rent(as % of GDP) of Natural Gas and Mineral Rent(as % of GDP) of Oil?
Make the answer very short. -0.71. In the year 1993, what is the difference between the Mineral Rent(as % of GDP) in Natural Gas and Mineral Rent(as % of GDP) in Other Minerals?
Ensure brevity in your answer.  0.32. In the year 1993, what is the difference between the Mineral Rent(as % of GDP) in Oil and Mineral Rent(as % of GDP) in Other Minerals?
Your answer should be compact. 1.03. In the year 1994, what is the difference between the Mineral Rent(as % of GDP) in Coal and Mineral Rent(as % of GDP) in Natural Gas?
Provide a succinct answer. -0.31. In the year 1994, what is the difference between the Mineral Rent(as % of GDP) of Coal and Mineral Rent(as % of GDP) of Oil?
Provide a short and direct response. -0.95. In the year 1994, what is the difference between the Mineral Rent(as % of GDP) in Coal and Mineral Rent(as % of GDP) in Other Minerals?
Keep it short and to the point. -0.07. In the year 1994, what is the difference between the Mineral Rent(as % of GDP) in Natural Gas and Mineral Rent(as % of GDP) in Oil?
Offer a terse response. -0.64. In the year 1994, what is the difference between the Mineral Rent(as % of GDP) of Natural Gas and Mineral Rent(as % of GDP) of Other Minerals?
Your response must be concise. 0.24. In the year 1994, what is the difference between the Mineral Rent(as % of GDP) in Oil and Mineral Rent(as % of GDP) in Other Minerals?
Your answer should be compact. 0.88. In the year 1995, what is the difference between the Mineral Rent(as % of GDP) in Coal and Mineral Rent(as % of GDP) in Natural Gas?
Your response must be concise. -0.29. In the year 1995, what is the difference between the Mineral Rent(as % of GDP) of Coal and Mineral Rent(as % of GDP) of Oil?
Keep it short and to the point. -0.95. In the year 1995, what is the difference between the Mineral Rent(as % of GDP) of Coal and Mineral Rent(as % of GDP) of Other Minerals?
Give a very brief answer. -0.07. In the year 1995, what is the difference between the Mineral Rent(as % of GDP) of Natural Gas and Mineral Rent(as % of GDP) of Oil?
Your answer should be compact. -0.67. In the year 1995, what is the difference between the Mineral Rent(as % of GDP) in Natural Gas and Mineral Rent(as % of GDP) in Other Minerals?
Give a very brief answer. 0.21. In the year 1995, what is the difference between the Mineral Rent(as % of GDP) in Oil and Mineral Rent(as % of GDP) in Other Minerals?
Offer a very short reply. 0.88. What is the ratio of the Mineral Rent(as % of GDP) in Coal in 1987 to that in 1988?
Keep it short and to the point. 0.73. What is the ratio of the Mineral Rent(as % of GDP) in Natural Gas in 1987 to that in 1988?
Give a very brief answer. 1.25. What is the ratio of the Mineral Rent(as % of GDP) in Oil in 1987 to that in 1988?
Ensure brevity in your answer.  1.43. What is the ratio of the Mineral Rent(as % of GDP) of Other Minerals in 1987 to that in 1988?
Ensure brevity in your answer.  0.44. What is the ratio of the Mineral Rent(as % of GDP) in Coal in 1987 to that in 1989?
Ensure brevity in your answer.  0.32. What is the ratio of the Mineral Rent(as % of GDP) in Natural Gas in 1987 to that in 1989?
Your answer should be very brief. 1. What is the ratio of the Mineral Rent(as % of GDP) in Oil in 1987 to that in 1989?
Make the answer very short. 0.94. What is the ratio of the Mineral Rent(as % of GDP) of Other Minerals in 1987 to that in 1989?
Provide a short and direct response. 0.55. What is the ratio of the Mineral Rent(as % of GDP) of Coal in 1987 to that in 1990?
Keep it short and to the point. 0.29. What is the ratio of the Mineral Rent(as % of GDP) of Natural Gas in 1987 to that in 1990?
Offer a very short reply. 0.71. What is the ratio of the Mineral Rent(as % of GDP) of Oil in 1987 to that in 1990?
Keep it short and to the point. 0.72. What is the ratio of the Mineral Rent(as % of GDP) of Other Minerals in 1987 to that in 1990?
Offer a very short reply. 0.78. What is the ratio of the Mineral Rent(as % of GDP) in Coal in 1987 to that in 1991?
Ensure brevity in your answer.  0.33. What is the ratio of the Mineral Rent(as % of GDP) of Natural Gas in 1987 to that in 1991?
Make the answer very short. 0.72. What is the ratio of the Mineral Rent(as % of GDP) in Oil in 1987 to that in 1991?
Offer a terse response. 1. What is the ratio of the Mineral Rent(as % of GDP) of Coal in 1987 to that in 1992?
Your answer should be very brief. 0.49. What is the ratio of the Mineral Rent(as % of GDP) in Natural Gas in 1987 to that in 1992?
Offer a very short reply. 0.9. What is the ratio of the Mineral Rent(as % of GDP) in Oil in 1987 to that in 1992?
Ensure brevity in your answer.  1.11. What is the ratio of the Mineral Rent(as % of GDP) of Other Minerals in 1987 to that in 1992?
Your answer should be compact. 1.15. What is the ratio of the Mineral Rent(as % of GDP) in Coal in 1987 to that in 1993?
Ensure brevity in your answer.  1.18. What is the ratio of the Mineral Rent(as % of GDP) of Natural Gas in 1987 to that in 1993?
Give a very brief answer. 0.7. What is the ratio of the Mineral Rent(as % of GDP) of Oil in 1987 to that in 1993?
Offer a very short reply. 1.21. What is the ratio of the Mineral Rent(as % of GDP) in Other Minerals in 1987 to that in 1993?
Your answer should be compact. 1.67. What is the ratio of the Mineral Rent(as % of GDP) in Coal in 1987 to that in 1994?
Give a very brief answer. 1.02. What is the ratio of the Mineral Rent(as % of GDP) in Natural Gas in 1987 to that in 1994?
Keep it short and to the point. 0.82. What is the ratio of the Mineral Rent(as % of GDP) in Oil in 1987 to that in 1994?
Offer a terse response. 1.38. What is the ratio of the Mineral Rent(as % of GDP) in Other Minerals in 1987 to that in 1994?
Offer a terse response. 1.35. What is the ratio of the Mineral Rent(as % of GDP) of Coal in 1987 to that in 1995?
Offer a very short reply. 0.65. What is the ratio of the Mineral Rent(as % of GDP) of Natural Gas in 1987 to that in 1995?
Your answer should be very brief. 0.87. What is the ratio of the Mineral Rent(as % of GDP) in Oil in 1987 to that in 1995?
Provide a short and direct response. 1.36. What is the ratio of the Mineral Rent(as % of GDP) in Other Minerals in 1987 to that in 1995?
Your answer should be very brief. 1.21. What is the ratio of the Mineral Rent(as % of GDP) of Coal in 1988 to that in 1989?
Ensure brevity in your answer.  0.44. What is the ratio of the Mineral Rent(as % of GDP) in Natural Gas in 1988 to that in 1989?
Offer a very short reply. 0.8. What is the ratio of the Mineral Rent(as % of GDP) in Oil in 1988 to that in 1989?
Your response must be concise. 0.66. What is the ratio of the Mineral Rent(as % of GDP) of Other Minerals in 1988 to that in 1989?
Offer a very short reply. 1.23. What is the ratio of the Mineral Rent(as % of GDP) of Coal in 1988 to that in 1990?
Offer a very short reply. 0.4. What is the ratio of the Mineral Rent(as % of GDP) in Natural Gas in 1988 to that in 1990?
Offer a terse response. 0.57. What is the ratio of the Mineral Rent(as % of GDP) of Oil in 1988 to that in 1990?
Give a very brief answer. 0.51. What is the ratio of the Mineral Rent(as % of GDP) of Other Minerals in 1988 to that in 1990?
Your answer should be very brief. 1.75. What is the ratio of the Mineral Rent(as % of GDP) in Coal in 1988 to that in 1991?
Offer a terse response. 0.46. What is the ratio of the Mineral Rent(as % of GDP) in Natural Gas in 1988 to that in 1991?
Offer a terse response. 0.58. What is the ratio of the Mineral Rent(as % of GDP) in Oil in 1988 to that in 1991?
Ensure brevity in your answer.  0.7. What is the ratio of the Mineral Rent(as % of GDP) in Other Minerals in 1988 to that in 1991?
Offer a terse response. 2.23. What is the ratio of the Mineral Rent(as % of GDP) in Coal in 1988 to that in 1992?
Provide a succinct answer. 0.67. What is the ratio of the Mineral Rent(as % of GDP) of Natural Gas in 1988 to that in 1992?
Ensure brevity in your answer.  0.72. What is the ratio of the Mineral Rent(as % of GDP) in Oil in 1988 to that in 1992?
Make the answer very short. 0.78. What is the ratio of the Mineral Rent(as % of GDP) of Other Minerals in 1988 to that in 1992?
Your answer should be very brief. 2.58. What is the ratio of the Mineral Rent(as % of GDP) of Coal in 1988 to that in 1993?
Your answer should be very brief. 1.62. What is the ratio of the Mineral Rent(as % of GDP) in Natural Gas in 1988 to that in 1993?
Make the answer very short. 0.56. What is the ratio of the Mineral Rent(as % of GDP) of Oil in 1988 to that in 1993?
Offer a very short reply. 0.85. What is the ratio of the Mineral Rent(as % of GDP) in Other Minerals in 1988 to that in 1993?
Your answer should be very brief. 3.76. What is the ratio of the Mineral Rent(as % of GDP) in Coal in 1988 to that in 1994?
Provide a succinct answer. 1.4. What is the ratio of the Mineral Rent(as % of GDP) of Natural Gas in 1988 to that in 1994?
Ensure brevity in your answer.  0.66. What is the ratio of the Mineral Rent(as % of GDP) of Oil in 1988 to that in 1994?
Your answer should be compact. 0.97. What is the ratio of the Mineral Rent(as % of GDP) in Other Minerals in 1988 to that in 1994?
Offer a terse response. 3.03. What is the ratio of the Mineral Rent(as % of GDP) of Coal in 1988 to that in 1995?
Your answer should be compact. 0.89. What is the ratio of the Mineral Rent(as % of GDP) of Natural Gas in 1988 to that in 1995?
Your answer should be compact. 0.7. What is the ratio of the Mineral Rent(as % of GDP) of Oil in 1988 to that in 1995?
Your answer should be very brief. 0.96. What is the ratio of the Mineral Rent(as % of GDP) of Other Minerals in 1988 to that in 1995?
Offer a very short reply. 2.71. What is the ratio of the Mineral Rent(as % of GDP) in Coal in 1989 to that in 1990?
Offer a very short reply. 0.89. What is the ratio of the Mineral Rent(as % of GDP) of Natural Gas in 1989 to that in 1990?
Ensure brevity in your answer.  0.7. What is the ratio of the Mineral Rent(as % of GDP) of Oil in 1989 to that in 1990?
Your answer should be compact. 0.77. What is the ratio of the Mineral Rent(as % of GDP) in Other Minerals in 1989 to that in 1990?
Provide a short and direct response. 1.42. What is the ratio of the Mineral Rent(as % of GDP) in Coal in 1989 to that in 1991?
Provide a succinct answer. 1.03. What is the ratio of the Mineral Rent(as % of GDP) of Natural Gas in 1989 to that in 1991?
Offer a terse response. 0.72. What is the ratio of the Mineral Rent(as % of GDP) in Oil in 1989 to that in 1991?
Provide a succinct answer. 1.07. What is the ratio of the Mineral Rent(as % of GDP) in Other Minerals in 1989 to that in 1991?
Offer a very short reply. 1.81. What is the ratio of the Mineral Rent(as % of GDP) of Coal in 1989 to that in 1992?
Provide a short and direct response. 1.52. What is the ratio of the Mineral Rent(as % of GDP) of Natural Gas in 1989 to that in 1992?
Offer a very short reply. 0.89. What is the ratio of the Mineral Rent(as % of GDP) in Oil in 1989 to that in 1992?
Provide a short and direct response. 1.18. What is the ratio of the Mineral Rent(as % of GDP) of Other Minerals in 1989 to that in 1992?
Keep it short and to the point. 2.1. What is the ratio of the Mineral Rent(as % of GDP) in Coal in 1989 to that in 1993?
Ensure brevity in your answer.  3.67. What is the ratio of the Mineral Rent(as % of GDP) in Natural Gas in 1989 to that in 1993?
Your answer should be compact. 0.69. What is the ratio of the Mineral Rent(as % of GDP) of Oil in 1989 to that in 1993?
Your answer should be compact. 1.29. What is the ratio of the Mineral Rent(as % of GDP) in Other Minerals in 1989 to that in 1993?
Your answer should be very brief. 3.06. What is the ratio of the Mineral Rent(as % of GDP) in Coal in 1989 to that in 1994?
Your response must be concise. 3.18. What is the ratio of the Mineral Rent(as % of GDP) in Natural Gas in 1989 to that in 1994?
Your answer should be very brief. 0.82. What is the ratio of the Mineral Rent(as % of GDP) in Oil in 1989 to that in 1994?
Offer a terse response. 1.47. What is the ratio of the Mineral Rent(as % of GDP) in Other Minerals in 1989 to that in 1994?
Give a very brief answer. 2.46. What is the ratio of the Mineral Rent(as % of GDP) in Coal in 1989 to that in 1995?
Offer a very short reply. 2.02. What is the ratio of the Mineral Rent(as % of GDP) of Natural Gas in 1989 to that in 1995?
Your response must be concise. 0.87. What is the ratio of the Mineral Rent(as % of GDP) in Oil in 1989 to that in 1995?
Ensure brevity in your answer.  1.45. What is the ratio of the Mineral Rent(as % of GDP) in Other Minerals in 1989 to that in 1995?
Your answer should be very brief. 2.2. What is the ratio of the Mineral Rent(as % of GDP) of Coal in 1990 to that in 1991?
Make the answer very short. 1.16. What is the ratio of the Mineral Rent(as % of GDP) of Natural Gas in 1990 to that in 1991?
Provide a succinct answer. 1.03. What is the ratio of the Mineral Rent(as % of GDP) of Oil in 1990 to that in 1991?
Ensure brevity in your answer.  1.39. What is the ratio of the Mineral Rent(as % of GDP) in Other Minerals in 1990 to that in 1991?
Offer a very short reply. 1.28. What is the ratio of the Mineral Rent(as % of GDP) in Coal in 1990 to that in 1992?
Your answer should be compact. 1.7. What is the ratio of the Mineral Rent(as % of GDP) in Natural Gas in 1990 to that in 1992?
Keep it short and to the point. 1.27. What is the ratio of the Mineral Rent(as % of GDP) of Oil in 1990 to that in 1992?
Provide a short and direct response. 1.54. What is the ratio of the Mineral Rent(as % of GDP) of Other Minerals in 1990 to that in 1992?
Offer a very short reply. 1.48. What is the ratio of the Mineral Rent(as % of GDP) of Coal in 1990 to that in 1993?
Give a very brief answer. 4.11. What is the ratio of the Mineral Rent(as % of GDP) of Natural Gas in 1990 to that in 1993?
Make the answer very short. 0.98. What is the ratio of the Mineral Rent(as % of GDP) of Oil in 1990 to that in 1993?
Make the answer very short. 1.68. What is the ratio of the Mineral Rent(as % of GDP) of Other Minerals in 1990 to that in 1993?
Offer a terse response. 2.15. What is the ratio of the Mineral Rent(as % of GDP) of Coal in 1990 to that in 1994?
Offer a very short reply. 3.55. What is the ratio of the Mineral Rent(as % of GDP) in Natural Gas in 1990 to that in 1994?
Provide a succinct answer. 1.17. What is the ratio of the Mineral Rent(as % of GDP) of Oil in 1990 to that in 1994?
Keep it short and to the point. 1.91. What is the ratio of the Mineral Rent(as % of GDP) of Other Minerals in 1990 to that in 1994?
Provide a short and direct response. 1.74. What is the ratio of the Mineral Rent(as % of GDP) in Coal in 1990 to that in 1995?
Your answer should be very brief. 2.26. What is the ratio of the Mineral Rent(as % of GDP) in Natural Gas in 1990 to that in 1995?
Provide a succinct answer. 1.23. What is the ratio of the Mineral Rent(as % of GDP) in Oil in 1990 to that in 1995?
Your answer should be compact. 1.88. What is the ratio of the Mineral Rent(as % of GDP) of Other Minerals in 1990 to that in 1995?
Your answer should be very brief. 1.55. What is the ratio of the Mineral Rent(as % of GDP) of Coal in 1991 to that in 1992?
Ensure brevity in your answer.  1.47. What is the ratio of the Mineral Rent(as % of GDP) in Natural Gas in 1991 to that in 1992?
Your answer should be very brief. 1.24. What is the ratio of the Mineral Rent(as % of GDP) of Oil in 1991 to that in 1992?
Keep it short and to the point. 1.11. What is the ratio of the Mineral Rent(as % of GDP) of Other Minerals in 1991 to that in 1992?
Provide a succinct answer. 1.16. What is the ratio of the Mineral Rent(as % of GDP) in Coal in 1991 to that in 1993?
Your answer should be very brief. 3.55. What is the ratio of the Mineral Rent(as % of GDP) of Natural Gas in 1991 to that in 1993?
Offer a terse response. 0.96. What is the ratio of the Mineral Rent(as % of GDP) in Oil in 1991 to that in 1993?
Offer a terse response. 1.21. What is the ratio of the Mineral Rent(as % of GDP) in Other Minerals in 1991 to that in 1993?
Provide a succinct answer. 1.68. What is the ratio of the Mineral Rent(as % of GDP) of Coal in 1991 to that in 1994?
Keep it short and to the point. 3.07. What is the ratio of the Mineral Rent(as % of GDP) in Natural Gas in 1991 to that in 1994?
Keep it short and to the point. 1.14. What is the ratio of the Mineral Rent(as % of GDP) in Oil in 1991 to that in 1994?
Provide a short and direct response. 1.38. What is the ratio of the Mineral Rent(as % of GDP) of Other Minerals in 1991 to that in 1994?
Keep it short and to the point. 1.36. What is the ratio of the Mineral Rent(as % of GDP) of Coal in 1991 to that in 1995?
Offer a very short reply. 1.95. What is the ratio of the Mineral Rent(as % of GDP) of Natural Gas in 1991 to that in 1995?
Give a very brief answer. 1.2. What is the ratio of the Mineral Rent(as % of GDP) of Oil in 1991 to that in 1995?
Give a very brief answer. 1.36. What is the ratio of the Mineral Rent(as % of GDP) in Other Minerals in 1991 to that in 1995?
Give a very brief answer. 1.22. What is the ratio of the Mineral Rent(as % of GDP) of Coal in 1992 to that in 1993?
Make the answer very short. 2.41. What is the ratio of the Mineral Rent(as % of GDP) of Natural Gas in 1992 to that in 1993?
Offer a terse response. 0.78. What is the ratio of the Mineral Rent(as % of GDP) of Oil in 1992 to that in 1993?
Make the answer very short. 1.09. What is the ratio of the Mineral Rent(as % of GDP) in Other Minerals in 1992 to that in 1993?
Keep it short and to the point. 1.46. What is the ratio of the Mineral Rent(as % of GDP) in Coal in 1992 to that in 1994?
Your answer should be very brief. 2.09. What is the ratio of the Mineral Rent(as % of GDP) of Natural Gas in 1992 to that in 1994?
Your answer should be compact. 0.92. What is the ratio of the Mineral Rent(as % of GDP) in Oil in 1992 to that in 1994?
Give a very brief answer. 1.24. What is the ratio of the Mineral Rent(as % of GDP) of Other Minerals in 1992 to that in 1994?
Your response must be concise. 1.17. What is the ratio of the Mineral Rent(as % of GDP) of Coal in 1992 to that in 1995?
Make the answer very short. 1.33. What is the ratio of the Mineral Rent(as % of GDP) in Natural Gas in 1992 to that in 1995?
Keep it short and to the point. 0.97. What is the ratio of the Mineral Rent(as % of GDP) in Oil in 1992 to that in 1995?
Give a very brief answer. 1.22. What is the ratio of the Mineral Rent(as % of GDP) of Other Minerals in 1992 to that in 1995?
Your answer should be compact. 1.05. What is the ratio of the Mineral Rent(as % of GDP) of Coal in 1993 to that in 1994?
Your answer should be very brief. 0.87. What is the ratio of the Mineral Rent(as % of GDP) in Natural Gas in 1993 to that in 1994?
Your answer should be compact. 1.18. What is the ratio of the Mineral Rent(as % of GDP) of Oil in 1993 to that in 1994?
Your answer should be compact. 1.14. What is the ratio of the Mineral Rent(as % of GDP) of Other Minerals in 1993 to that in 1994?
Offer a terse response. 0.81. What is the ratio of the Mineral Rent(as % of GDP) of Coal in 1993 to that in 1995?
Offer a terse response. 0.55. What is the ratio of the Mineral Rent(as % of GDP) of Natural Gas in 1993 to that in 1995?
Provide a short and direct response. 1.25. What is the ratio of the Mineral Rent(as % of GDP) of Oil in 1993 to that in 1995?
Make the answer very short. 1.12. What is the ratio of the Mineral Rent(as % of GDP) in Other Minerals in 1993 to that in 1995?
Offer a very short reply. 0.72. What is the ratio of the Mineral Rent(as % of GDP) of Coal in 1994 to that in 1995?
Your response must be concise. 0.64. What is the ratio of the Mineral Rent(as % of GDP) in Natural Gas in 1994 to that in 1995?
Ensure brevity in your answer.  1.06. What is the ratio of the Mineral Rent(as % of GDP) in Oil in 1994 to that in 1995?
Offer a terse response. 0.99. What is the ratio of the Mineral Rent(as % of GDP) in Other Minerals in 1994 to that in 1995?
Provide a succinct answer. 0.89. What is the difference between the highest and the second highest Mineral Rent(as % of GDP) in Coal?
Ensure brevity in your answer.  0.01. What is the difference between the highest and the second highest Mineral Rent(as % of GDP) of Natural Gas?
Your answer should be compact. 0.01. What is the difference between the highest and the second highest Mineral Rent(as % of GDP) in Oil?
Your answer should be very brief. 0.42. What is the difference between the highest and the second highest Mineral Rent(as % of GDP) in Other Minerals?
Give a very brief answer. 0.05. What is the difference between the highest and the lowest Mineral Rent(as % of GDP) in Coal?
Provide a short and direct response. 0.04. What is the difference between the highest and the lowest Mineral Rent(as % of GDP) in Natural Gas?
Your response must be concise. 0.17. What is the difference between the highest and the lowest Mineral Rent(as % of GDP) in Oil?
Provide a succinct answer. 0.91. What is the difference between the highest and the lowest Mineral Rent(as % of GDP) of Other Minerals?
Keep it short and to the point. 0.19. 